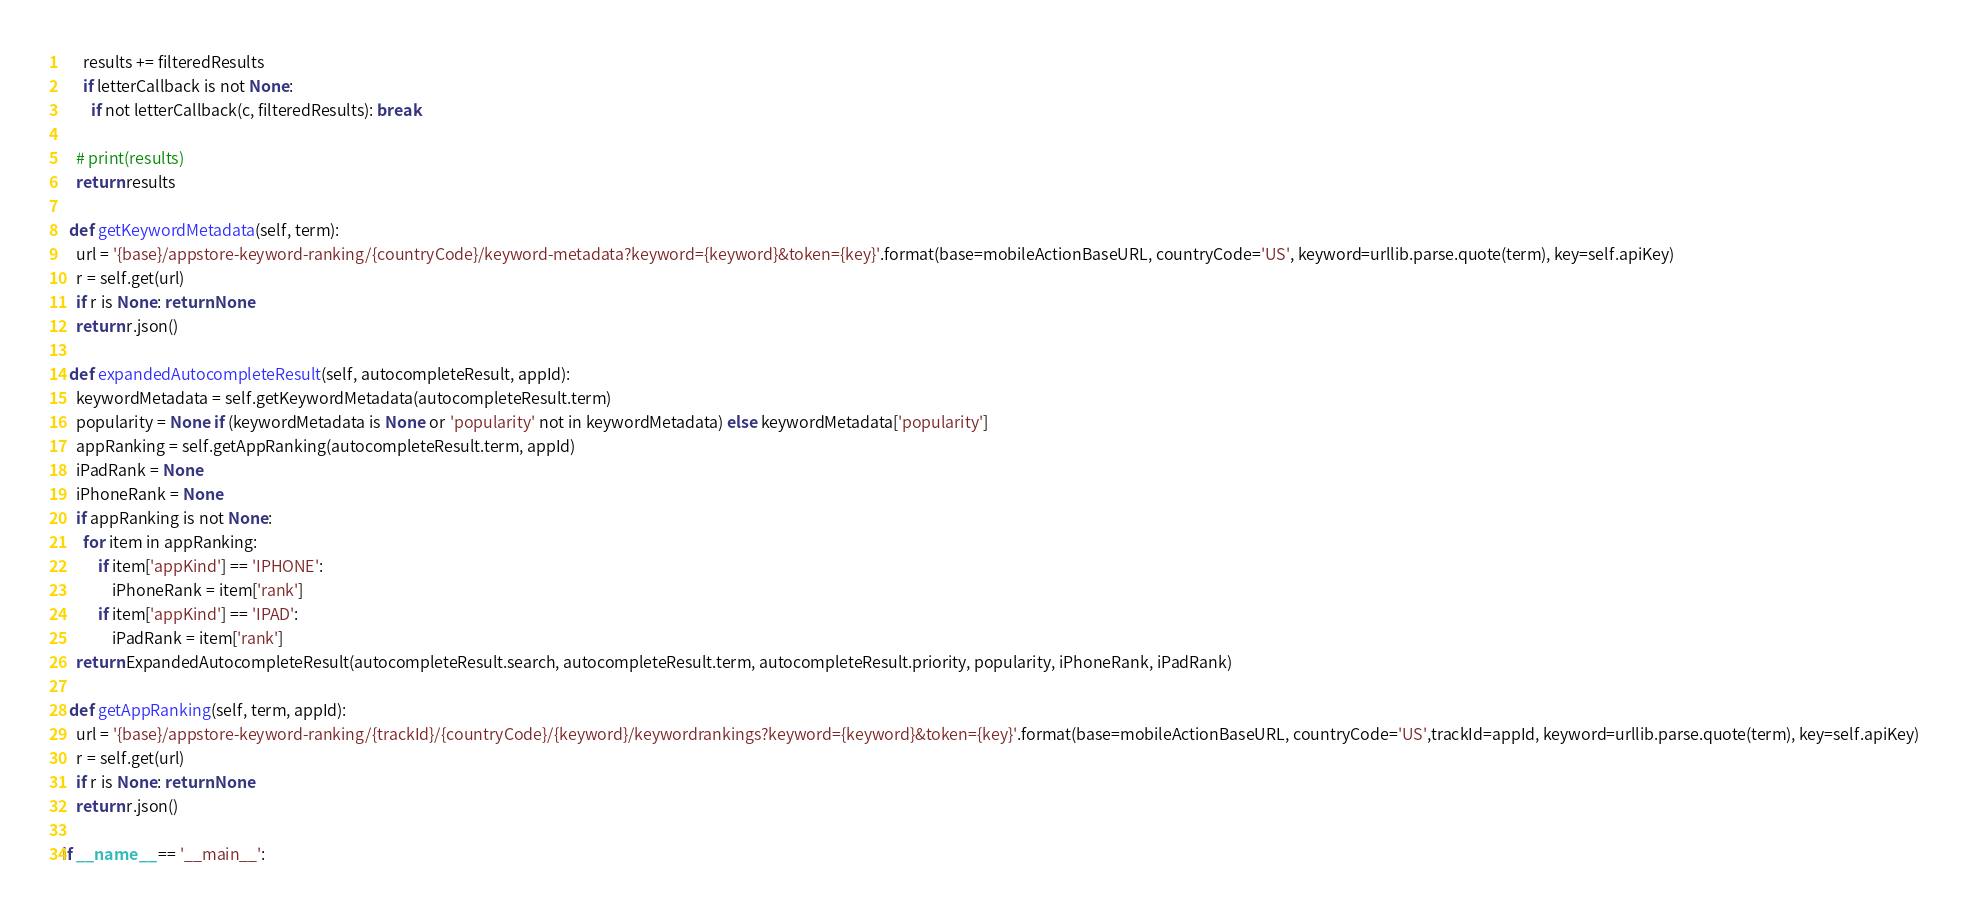Convert code to text. <code><loc_0><loc_0><loc_500><loc_500><_Python_>      results += filteredResults
      if letterCallback is not None:
        if not letterCallback(c, filteredResults): break

    # print(results)
    return results

  def getKeywordMetadata(self, term):
    url = '{base}/appstore-keyword-ranking/{countryCode}/keyword-metadata?keyword={keyword}&token={key}'.format(base=mobileActionBaseURL, countryCode='US', keyword=urllib.parse.quote(term), key=self.apiKey)
    r = self.get(url)
    if r is None: return None
    return r.json()

  def expandedAutocompleteResult(self, autocompleteResult, appId):
    keywordMetadata = self.getKeywordMetadata(autocompleteResult.term)
    popularity = None if (keywordMetadata is None or 'popularity' not in keywordMetadata) else keywordMetadata['popularity']
    appRanking = self.getAppRanking(autocompleteResult.term, appId)
    iPadRank = None
    iPhoneRank = None
    if appRanking is not None:
      for item in appRanking:
          if item['appKind'] == 'IPHONE':
              iPhoneRank = item['rank']
          if item['appKind'] == 'IPAD':
              iPadRank = item['rank']
    return ExpandedAutocompleteResult(autocompleteResult.search, autocompleteResult.term, autocompleteResult.priority, popularity, iPhoneRank, iPadRank)

  def getAppRanking(self, term, appId):
    url = '{base}/appstore-keyword-ranking/{trackId}/{countryCode}/{keyword}/keywordrankings?keyword={keyword}&token={key}'.format(base=mobileActionBaseURL, countryCode='US',trackId=appId, keyword=urllib.parse.quote(term), key=self.apiKey)
    r = self.get(url)
    if r is None: return None
    return r.json()

if __name__ == '__main__':</code> 